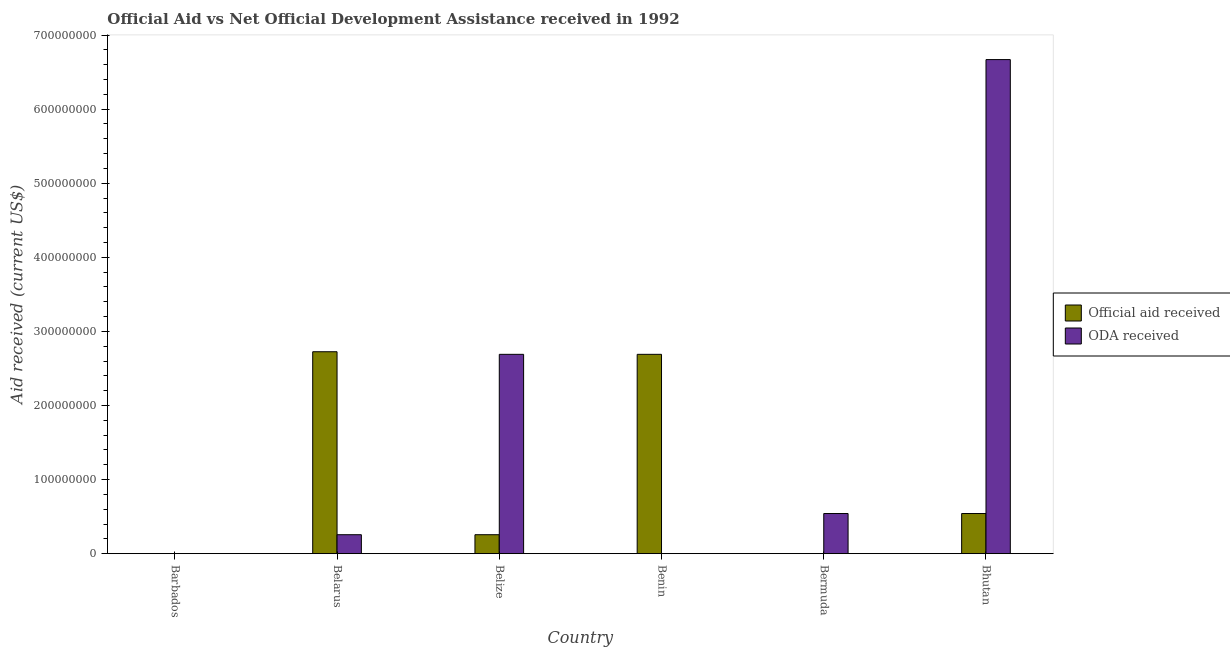Are the number of bars on each tick of the X-axis equal?
Make the answer very short. No. How many bars are there on the 4th tick from the left?
Give a very brief answer. 1. What is the label of the 5th group of bars from the left?
Give a very brief answer. Bermuda. In how many cases, is the number of bars for a given country not equal to the number of legend labels?
Keep it short and to the point. 2. What is the official aid received in Bhutan?
Ensure brevity in your answer.  5.42e+07. Across all countries, what is the maximum oda received?
Your answer should be very brief. 6.67e+08. Across all countries, what is the minimum official aid received?
Give a very brief answer. 0. In which country was the official aid received maximum?
Offer a terse response. Belarus. What is the total oda received in the graph?
Your answer should be compact. 1.02e+09. What is the difference between the oda received in Barbados and that in Belize?
Your response must be concise. -2.69e+08. What is the difference between the oda received in Bermuda and the official aid received in Bhutan?
Offer a very short reply. 0. What is the average oda received per country?
Give a very brief answer. 1.69e+08. What is the difference between the oda received and official aid received in Belarus?
Make the answer very short. -2.47e+08. What is the ratio of the official aid received in Barbados to that in Bhutan?
Ensure brevity in your answer.  0. Is the official aid received in Belarus less than that in Benin?
Provide a succinct answer. No. Is the difference between the oda received in Barbados and Belarus greater than the difference between the official aid received in Barbados and Belarus?
Keep it short and to the point. Yes. What is the difference between the highest and the second highest oda received?
Your answer should be compact. 3.98e+08. What is the difference between the highest and the lowest oda received?
Keep it short and to the point. 6.67e+08. In how many countries, is the oda received greater than the average oda received taken over all countries?
Provide a short and direct response. 2. Is the sum of the official aid received in Barbados and Belize greater than the maximum oda received across all countries?
Your response must be concise. No. How many countries are there in the graph?
Your response must be concise. 6. What is the difference between two consecutive major ticks on the Y-axis?
Make the answer very short. 1.00e+08. Are the values on the major ticks of Y-axis written in scientific E-notation?
Give a very brief answer. No. Where does the legend appear in the graph?
Your answer should be compact. Center right. What is the title of the graph?
Ensure brevity in your answer.  Official Aid vs Net Official Development Assistance received in 1992 . Does "Primary income" appear as one of the legend labels in the graph?
Make the answer very short. No. What is the label or title of the Y-axis?
Make the answer very short. Aid received (current US$). What is the Aid received (current US$) in Official aid received in Barbados?
Your answer should be compact. 3.00e+04. What is the Aid received (current US$) in ODA received in Barbados?
Your answer should be very brief. 3.00e+04. What is the Aid received (current US$) in Official aid received in Belarus?
Your answer should be very brief. 2.73e+08. What is the Aid received (current US$) of ODA received in Belarus?
Offer a terse response. 2.56e+07. What is the Aid received (current US$) of Official aid received in Belize?
Your response must be concise. 2.56e+07. What is the Aid received (current US$) of ODA received in Belize?
Ensure brevity in your answer.  2.69e+08. What is the Aid received (current US$) in Official aid received in Benin?
Your answer should be very brief. 2.69e+08. What is the Aid received (current US$) of Official aid received in Bermuda?
Your response must be concise. 0. What is the Aid received (current US$) in ODA received in Bermuda?
Your answer should be very brief. 5.42e+07. What is the Aid received (current US$) of Official aid received in Bhutan?
Your answer should be compact. 5.42e+07. What is the Aid received (current US$) in ODA received in Bhutan?
Provide a succinct answer. 6.67e+08. Across all countries, what is the maximum Aid received (current US$) of Official aid received?
Offer a terse response. 2.73e+08. Across all countries, what is the maximum Aid received (current US$) of ODA received?
Your answer should be very brief. 6.67e+08. What is the total Aid received (current US$) of Official aid received in the graph?
Make the answer very short. 6.21e+08. What is the total Aid received (current US$) of ODA received in the graph?
Make the answer very short. 1.02e+09. What is the difference between the Aid received (current US$) of Official aid received in Barbados and that in Belarus?
Your answer should be very brief. -2.73e+08. What is the difference between the Aid received (current US$) of ODA received in Barbados and that in Belarus?
Offer a very short reply. -2.55e+07. What is the difference between the Aid received (current US$) in Official aid received in Barbados and that in Belize?
Make the answer very short. -2.55e+07. What is the difference between the Aid received (current US$) of ODA received in Barbados and that in Belize?
Offer a terse response. -2.69e+08. What is the difference between the Aid received (current US$) of Official aid received in Barbados and that in Benin?
Offer a very short reply. -2.69e+08. What is the difference between the Aid received (current US$) of ODA received in Barbados and that in Bermuda?
Make the answer very short. -5.41e+07. What is the difference between the Aid received (current US$) in Official aid received in Barbados and that in Bhutan?
Offer a terse response. -5.41e+07. What is the difference between the Aid received (current US$) of ODA received in Barbados and that in Bhutan?
Your answer should be very brief. -6.67e+08. What is the difference between the Aid received (current US$) in Official aid received in Belarus and that in Belize?
Provide a succinct answer. 2.47e+08. What is the difference between the Aid received (current US$) in ODA received in Belarus and that in Belize?
Your response must be concise. -2.43e+08. What is the difference between the Aid received (current US$) of Official aid received in Belarus and that in Benin?
Make the answer very short. 3.50e+06. What is the difference between the Aid received (current US$) in ODA received in Belarus and that in Bermuda?
Offer a terse response. -2.86e+07. What is the difference between the Aid received (current US$) in Official aid received in Belarus and that in Bhutan?
Your answer should be very brief. 2.18e+08. What is the difference between the Aid received (current US$) of ODA received in Belarus and that in Bhutan?
Provide a succinct answer. -6.41e+08. What is the difference between the Aid received (current US$) in Official aid received in Belize and that in Benin?
Provide a succinct answer. -2.43e+08. What is the difference between the Aid received (current US$) in ODA received in Belize and that in Bermuda?
Make the answer very short. 2.15e+08. What is the difference between the Aid received (current US$) in Official aid received in Belize and that in Bhutan?
Your answer should be very brief. -2.86e+07. What is the difference between the Aid received (current US$) in ODA received in Belize and that in Bhutan?
Keep it short and to the point. -3.98e+08. What is the difference between the Aid received (current US$) of Official aid received in Benin and that in Bhutan?
Keep it short and to the point. 2.15e+08. What is the difference between the Aid received (current US$) of ODA received in Bermuda and that in Bhutan?
Your answer should be compact. -6.13e+08. What is the difference between the Aid received (current US$) in Official aid received in Barbados and the Aid received (current US$) in ODA received in Belarus?
Provide a short and direct response. -2.55e+07. What is the difference between the Aid received (current US$) in Official aid received in Barbados and the Aid received (current US$) in ODA received in Belize?
Your answer should be compact. -2.69e+08. What is the difference between the Aid received (current US$) in Official aid received in Barbados and the Aid received (current US$) in ODA received in Bermuda?
Offer a very short reply. -5.41e+07. What is the difference between the Aid received (current US$) of Official aid received in Barbados and the Aid received (current US$) of ODA received in Bhutan?
Keep it short and to the point. -6.67e+08. What is the difference between the Aid received (current US$) of Official aid received in Belarus and the Aid received (current US$) of ODA received in Belize?
Make the answer very short. 3.50e+06. What is the difference between the Aid received (current US$) in Official aid received in Belarus and the Aid received (current US$) in ODA received in Bermuda?
Make the answer very short. 2.18e+08. What is the difference between the Aid received (current US$) of Official aid received in Belarus and the Aid received (current US$) of ODA received in Bhutan?
Your response must be concise. -3.94e+08. What is the difference between the Aid received (current US$) in Official aid received in Belize and the Aid received (current US$) in ODA received in Bermuda?
Keep it short and to the point. -2.86e+07. What is the difference between the Aid received (current US$) in Official aid received in Belize and the Aid received (current US$) in ODA received in Bhutan?
Provide a succinct answer. -6.41e+08. What is the difference between the Aid received (current US$) in Official aid received in Benin and the Aid received (current US$) in ODA received in Bermuda?
Ensure brevity in your answer.  2.15e+08. What is the difference between the Aid received (current US$) in Official aid received in Benin and the Aid received (current US$) in ODA received in Bhutan?
Make the answer very short. -3.98e+08. What is the average Aid received (current US$) of Official aid received per country?
Offer a very short reply. 1.04e+08. What is the average Aid received (current US$) of ODA received per country?
Ensure brevity in your answer.  1.69e+08. What is the difference between the Aid received (current US$) in Official aid received and Aid received (current US$) in ODA received in Barbados?
Your answer should be very brief. 0. What is the difference between the Aid received (current US$) of Official aid received and Aid received (current US$) of ODA received in Belarus?
Your answer should be compact. 2.47e+08. What is the difference between the Aid received (current US$) in Official aid received and Aid received (current US$) in ODA received in Belize?
Your response must be concise. -2.43e+08. What is the difference between the Aid received (current US$) in Official aid received and Aid received (current US$) in ODA received in Bhutan?
Offer a terse response. -6.13e+08. What is the ratio of the Aid received (current US$) of Official aid received in Barbados to that in Belarus?
Your answer should be compact. 0. What is the ratio of the Aid received (current US$) in ODA received in Barbados to that in Belarus?
Ensure brevity in your answer.  0. What is the ratio of the Aid received (current US$) in Official aid received in Barbados to that in Belize?
Keep it short and to the point. 0. What is the ratio of the Aid received (current US$) of ODA received in Barbados to that in Belize?
Provide a short and direct response. 0. What is the ratio of the Aid received (current US$) of ODA received in Barbados to that in Bermuda?
Make the answer very short. 0. What is the ratio of the Aid received (current US$) in Official aid received in Barbados to that in Bhutan?
Ensure brevity in your answer.  0. What is the ratio of the Aid received (current US$) in Official aid received in Belarus to that in Belize?
Offer a terse response. 10.66. What is the ratio of the Aid received (current US$) of ODA received in Belarus to that in Belize?
Provide a succinct answer. 0.1. What is the ratio of the Aid received (current US$) of Official aid received in Belarus to that in Benin?
Offer a terse response. 1.01. What is the ratio of the Aid received (current US$) in ODA received in Belarus to that in Bermuda?
Make the answer very short. 0.47. What is the ratio of the Aid received (current US$) in Official aid received in Belarus to that in Bhutan?
Give a very brief answer. 5.03. What is the ratio of the Aid received (current US$) in ODA received in Belarus to that in Bhutan?
Give a very brief answer. 0.04. What is the ratio of the Aid received (current US$) of Official aid received in Belize to that in Benin?
Your answer should be compact. 0.1. What is the ratio of the Aid received (current US$) of ODA received in Belize to that in Bermuda?
Offer a very short reply. 4.97. What is the ratio of the Aid received (current US$) in Official aid received in Belize to that in Bhutan?
Your answer should be very brief. 0.47. What is the ratio of the Aid received (current US$) of ODA received in Belize to that in Bhutan?
Offer a terse response. 0.4. What is the ratio of the Aid received (current US$) in Official aid received in Benin to that in Bhutan?
Provide a succinct answer. 4.97. What is the ratio of the Aid received (current US$) in ODA received in Bermuda to that in Bhutan?
Ensure brevity in your answer.  0.08. What is the difference between the highest and the second highest Aid received (current US$) of Official aid received?
Offer a very short reply. 3.50e+06. What is the difference between the highest and the second highest Aid received (current US$) of ODA received?
Provide a succinct answer. 3.98e+08. What is the difference between the highest and the lowest Aid received (current US$) in Official aid received?
Keep it short and to the point. 2.73e+08. What is the difference between the highest and the lowest Aid received (current US$) in ODA received?
Offer a terse response. 6.67e+08. 